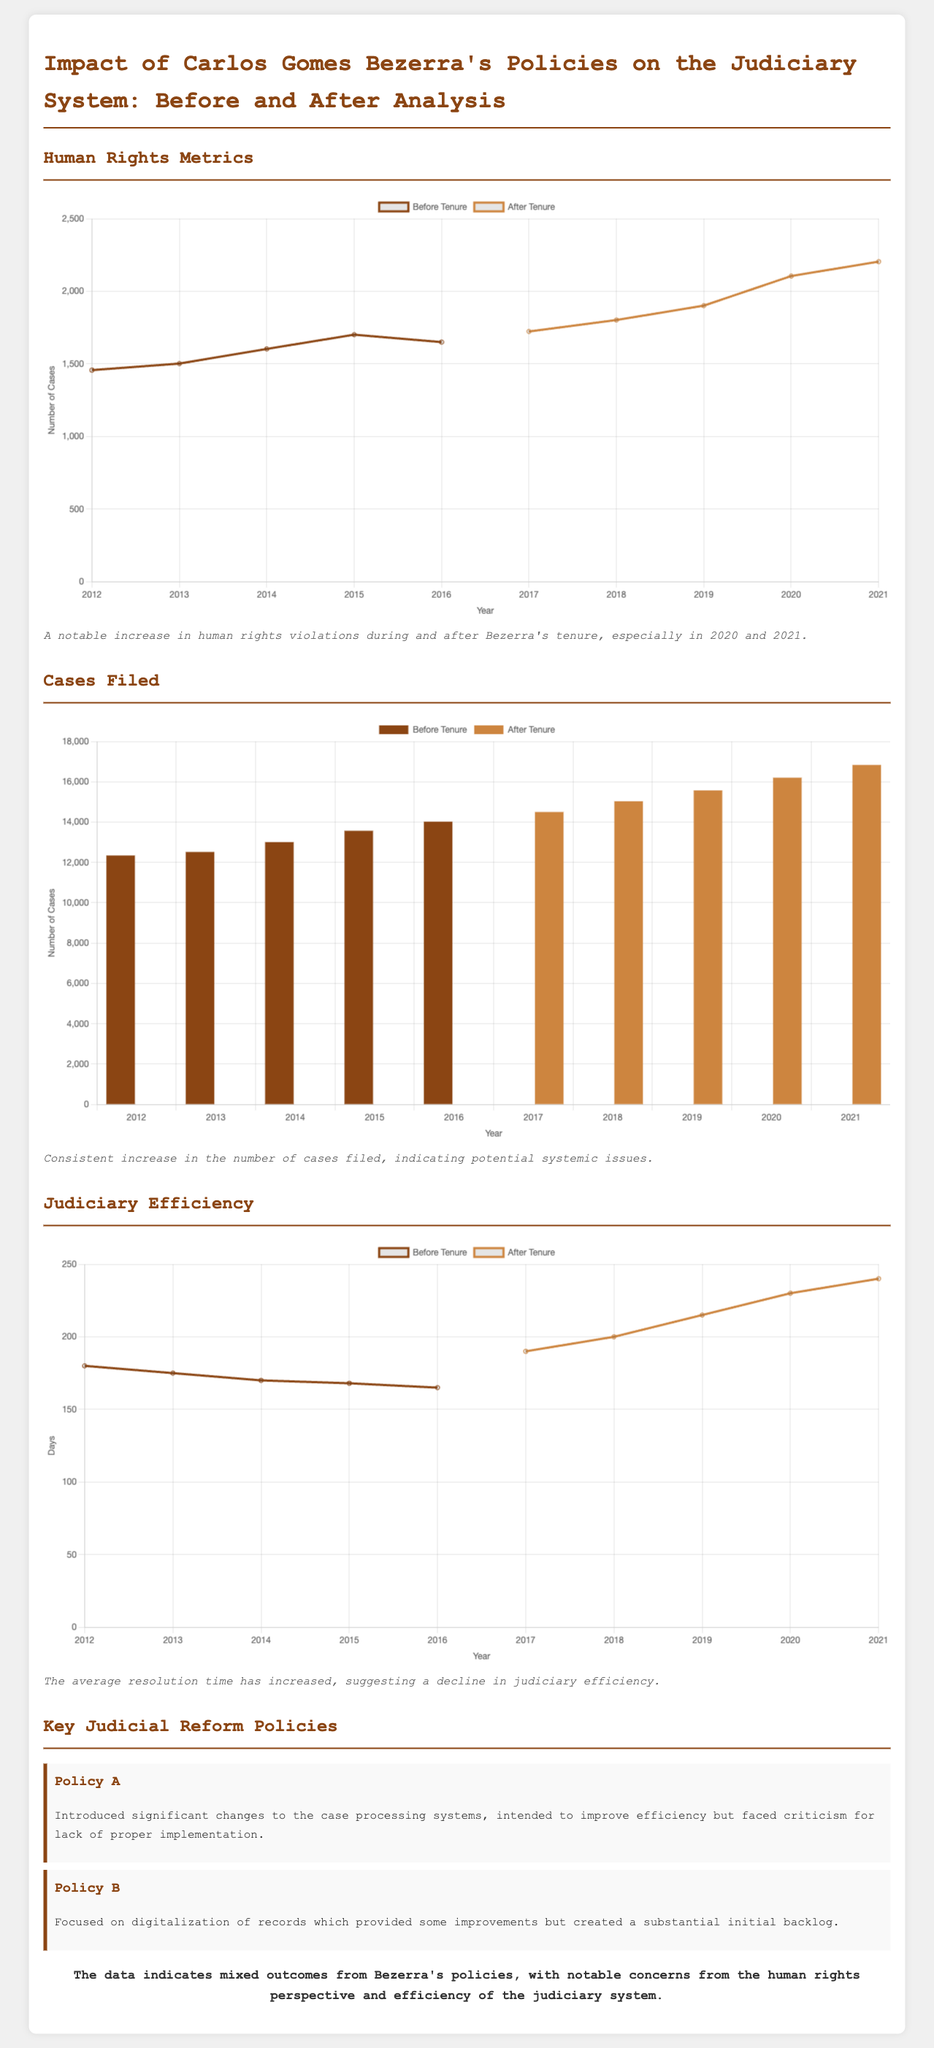What was the number of human rights violations in 2021? The number of human rights violations in 2021 can be found on the chart, indicating a notable increase during that year.
Answer: 2204 What significant change did Policy A introduce? The document states that Policy A introduced significant changes to the case processing systems aimed at improving efficiency.
Answer: Case processing systems What trend is observed in the number of cases filed from 2012 to 2021? The chart shows a consistent increase in the number of cases filed, which suggests a growing concern in the judiciary system.
Answer: Increase What was the average case resolution time in 2020? According to the judiciary efficiency chart, the average case resolution time for that year reflects an upward trend, requiring comparison from prior years.
Answer: 230 Which year showed the most significant increase in human rights violations after Bezerra's tenure began? By analyzing the human rights metrics, it can be determined that 2021 had one of the highest increases in violations recorded.
Answer: 2021 How many cases were filed in 2013? The bar chart provides the exact number of cases filed in that year, which indicates the judicial activity during Bezerra’s early period.
Answer: 12520 What is the overall annotation regarding Bezerra's policies? The final annotation summarizes the outcome of Bezerra's policies, indicating public perception of their effectiveness in the judiciary context.
Answer: Mixed outcomes When did the average case resolution time begin to increase? By analyzing the judiciary efficiency chart, it's clear that the increase in average case resolution time began after Bezerra took office in 2017.
Answer: 2017 